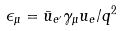<formula> <loc_0><loc_0><loc_500><loc_500>\epsilon _ { \mu } = \bar { u } _ { e ^ { \prime } } \gamma _ { \mu } u _ { e } / q ^ { 2 }</formula> 